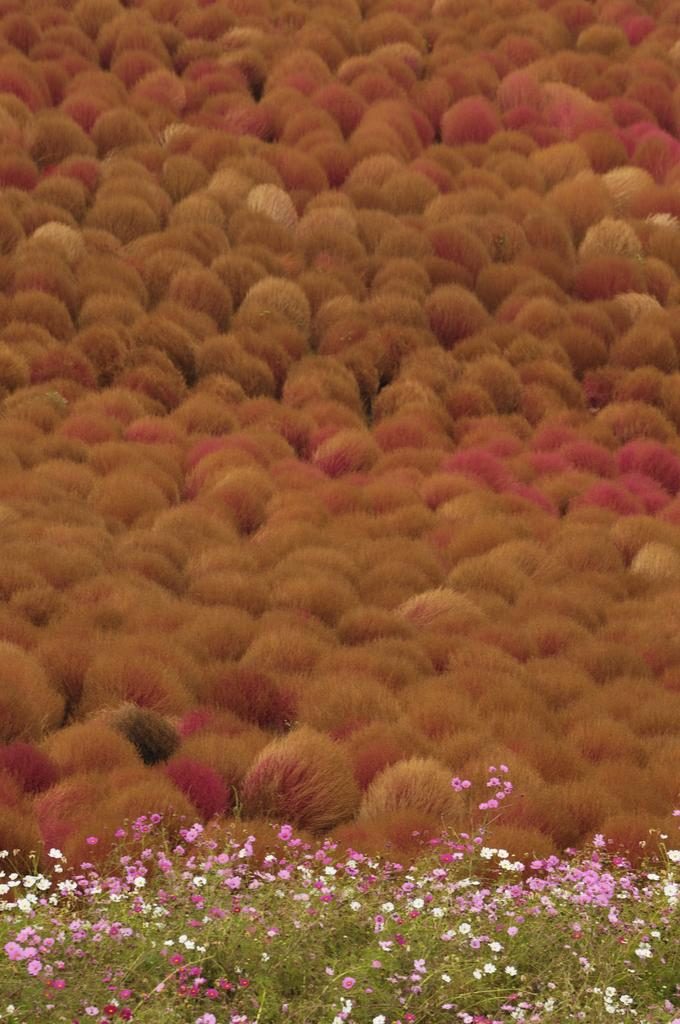What type of living organisms can be seen in the image? Plants can be seen in the image. Can you describe the flowers present in the image? There are flowers of different colors in the image. What type of ring can be seen on the flower in the image? There is no ring present on any of the flowers in the image. What material is the iron used to make the flowers in the image? The flowers in the image are not made of iron; they are natural flowers. 